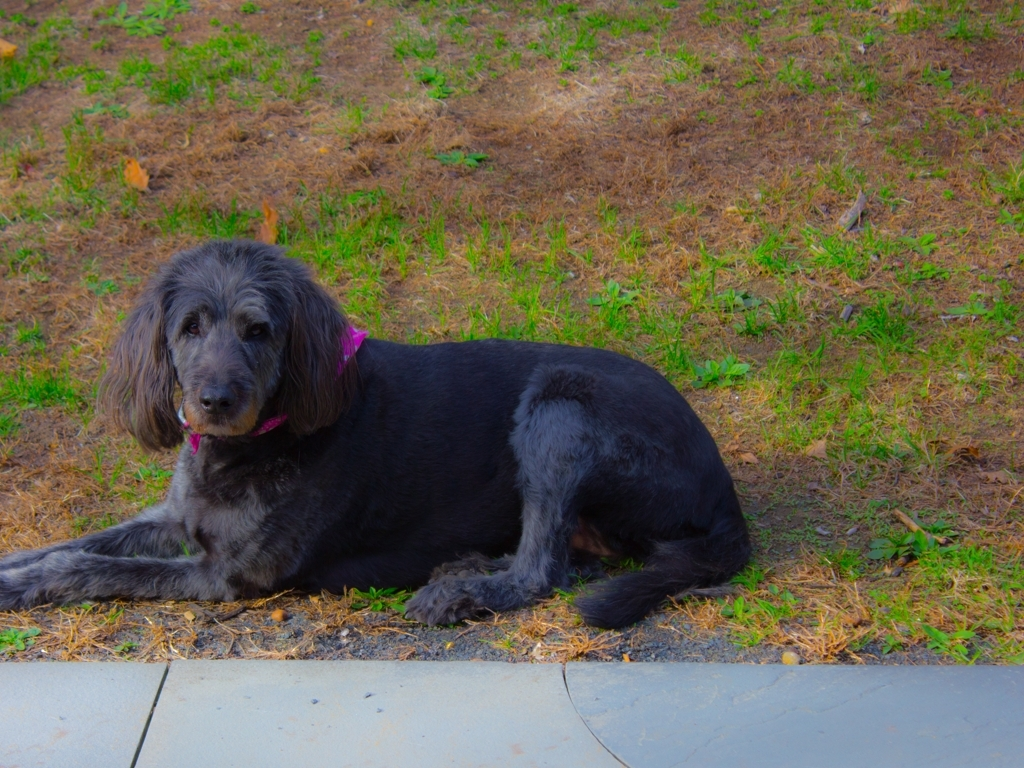What breed of dog does this appear to be? Based on the image, the dog appears to resemble traits of a standard poodle, known for their curly coats and intelligent expressions, though specific breed identification cannot be confirmed without more information. 